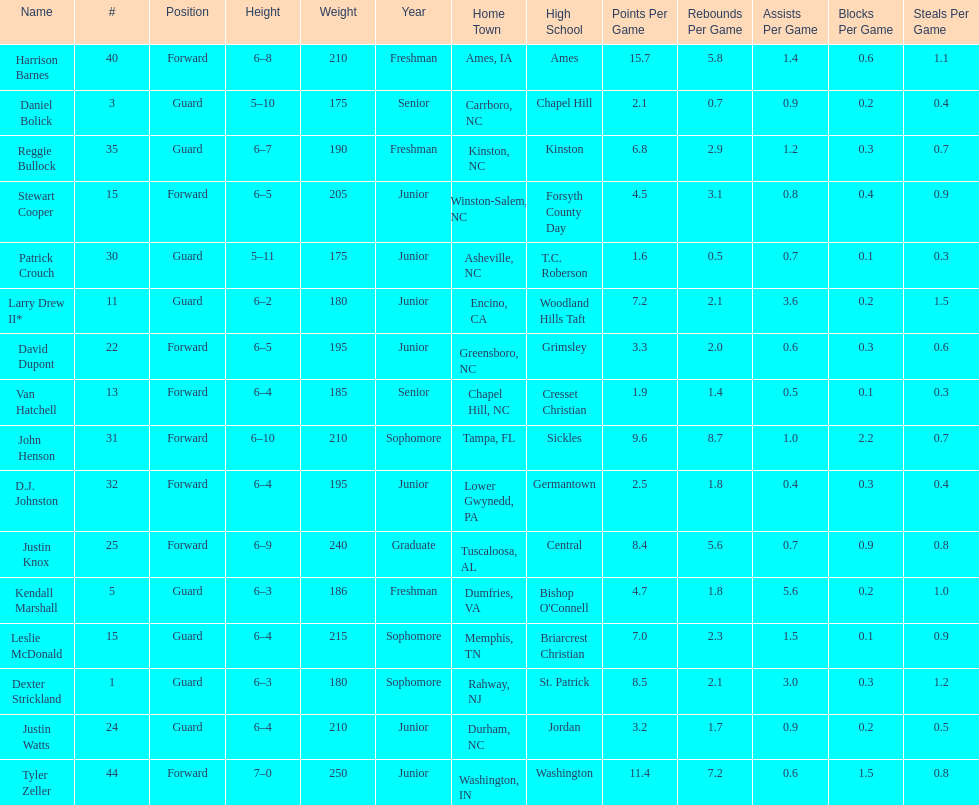What is the number of players with a weight over 200? 7. 